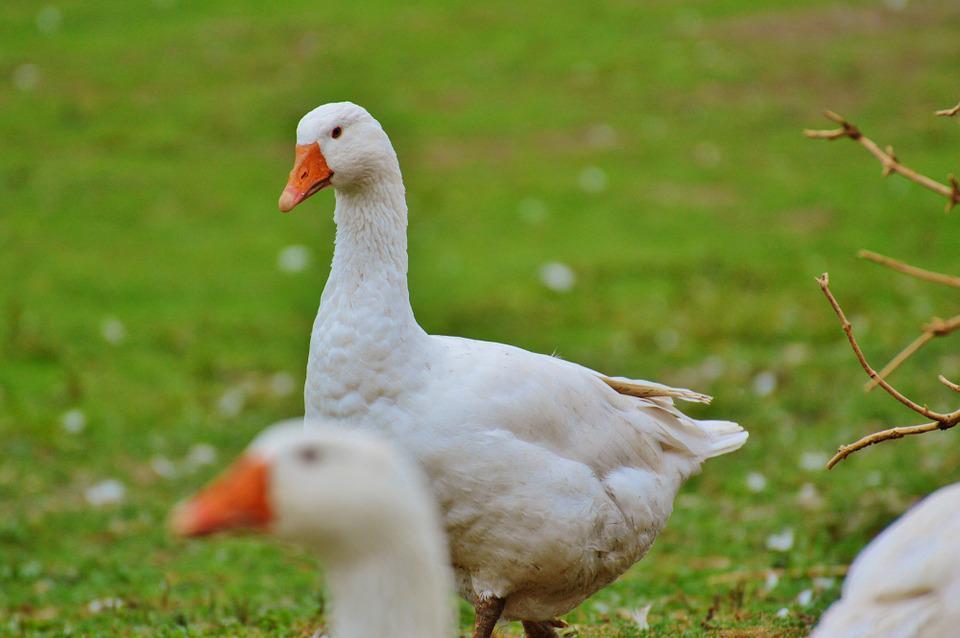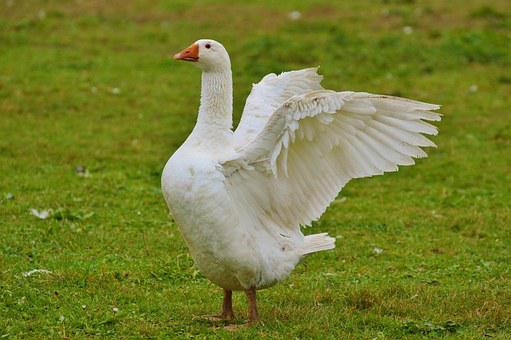The first image is the image on the left, the second image is the image on the right. Examine the images to the left and right. Is the description "There are two geese" accurate? Answer yes or no. No. 